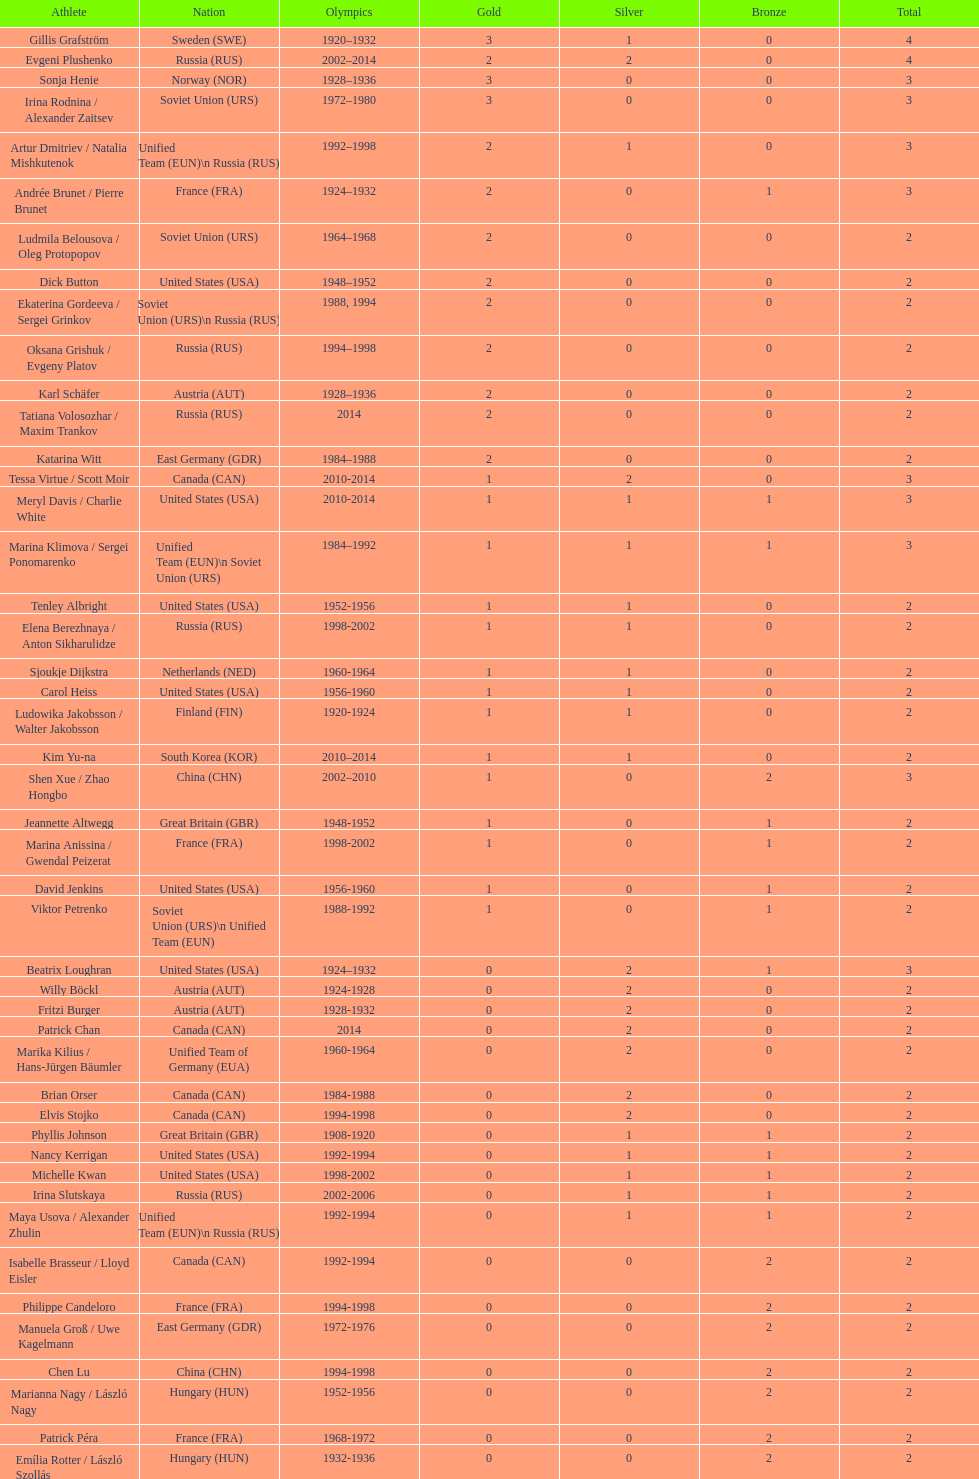Which athlete was from south korea after the year 2010? Kim Yu-na. 